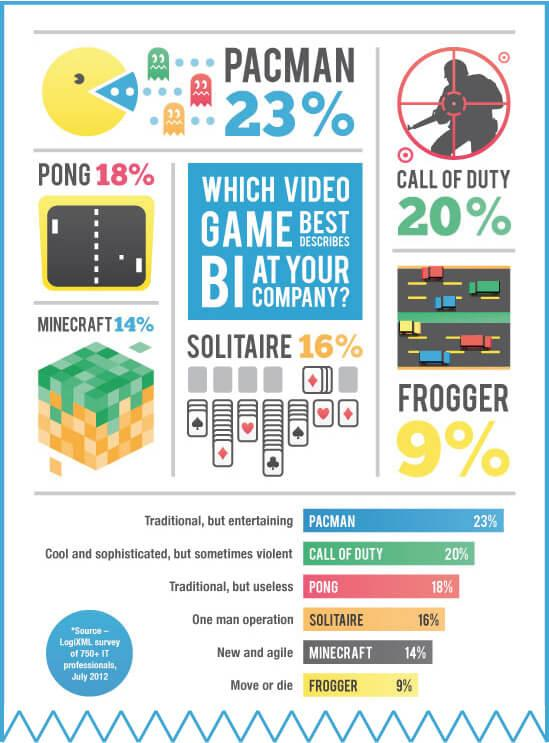Specify some key components in this picture. It is the case that the game with cards is Solitaire. I declare that the game that has a shooter is Call of Duty. In Frogger, there are a total of 6 vehicles displayed. 